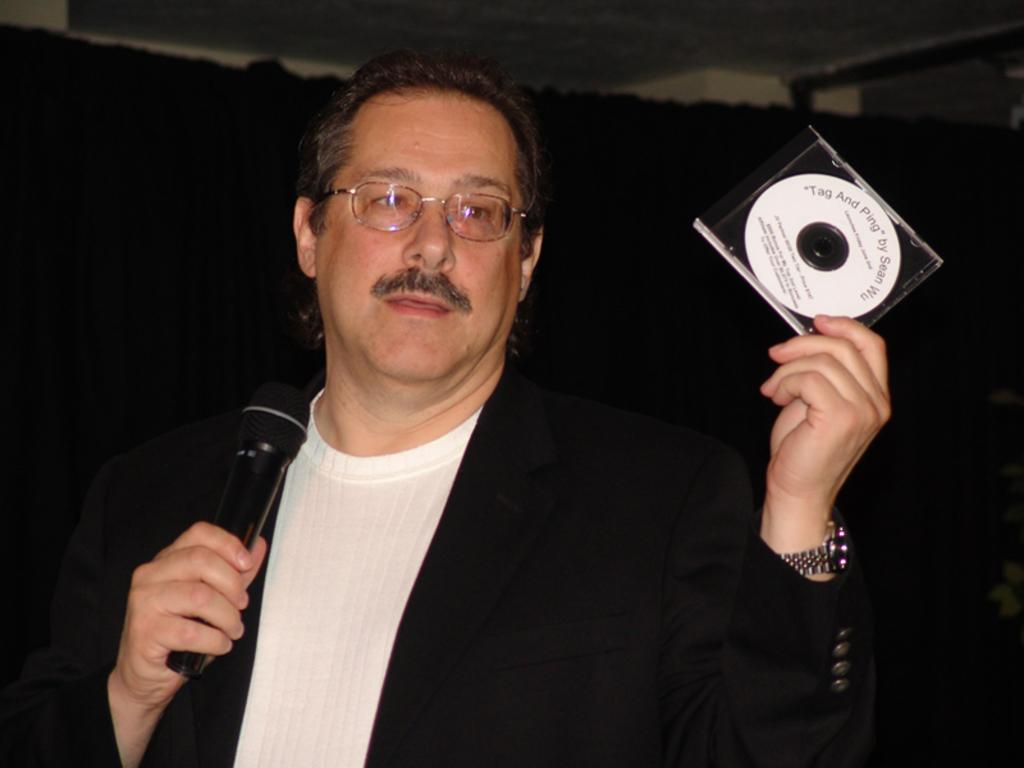What is the person in the image holding? The person is holding a microphone in the image. Can you describe any other objects in the image? There is an object in the image, but its specific details are not mentioned in the facts. What can be seen in the background of the image? There is a wall and the roof visible in the background of the image. Is there an umbrella being used to channel the turkey in the image? There is no mention of an umbrella, channel, or turkey in the image, so this scenario is not present. 